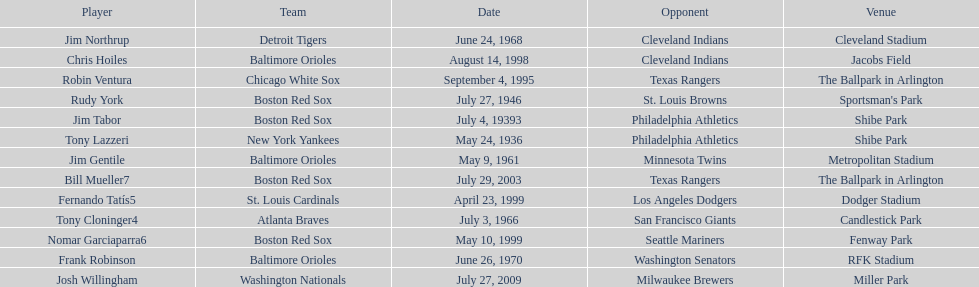Which teams faced off at miller park? Washington Nationals, Milwaukee Brewers. Could you help me parse every detail presented in this table? {'header': ['Player', 'Team', 'Date', 'Opponent', 'Venue'], 'rows': [['Jim Northrup', 'Detroit Tigers', 'June 24, 1968', 'Cleveland Indians', 'Cleveland Stadium'], ['Chris Hoiles', 'Baltimore Orioles', 'August 14, 1998', 'Cleveland Indians', 'Jacobs Field'], ['Robin Ventura', 'Chicago White Sox', 'September 4, 1995', 'Texas Rangers', 'The Ballpark in Arlington'], ['Rudy York', 'Boston Red Sox', 'July 27, 1946', 'St. Louis Browns', "Sportsman's Park"], ['Jim Tabor', 'Boston Red Sox', 'July 4, 19393', 'Philadelphia Athletics', 'Shibe Park'], ['Tony Lazzeri', 'New York Yankees', 'May 24, 1936', 'Philadelphia Athletics', 'Shibe Park'], ['Jim Gentile', 'Baltimore Orioles', 'May 9, 1961', 'Minnesota Twins', 'Metropolitan Stadium'], ['Bill Mueller7', 'Boston Red Sox', 'July 29, 2003', 'Texas Rangers', 'The Ballpark in Arlington'], ['Fernando Tatís5', 'St. Louis Cardinals', 'April 23, 1999', 'Los Angeles Dodgers', 'Dodger Stadium'], ['Tony Cloninger4', 'Atlanta Braves', 'July 3, 1966', 'San Francisco Giants', 'Candlestick Park'], ['Nomar Garciaparra6', 'Boston Red Sox', 'May 10, 1999', 'Seattle Mariners', 'Fenway Park'], ['Frank Robinson', 'Baltimore Orioles', 'June 26, 1970', 'Washington Senators', 'RFK Stadium'], ['Josh Willingham', 'Washington Nationals', 'July 27, 2009', 'Milwaukee Brewers', 'Miller Park']]} 